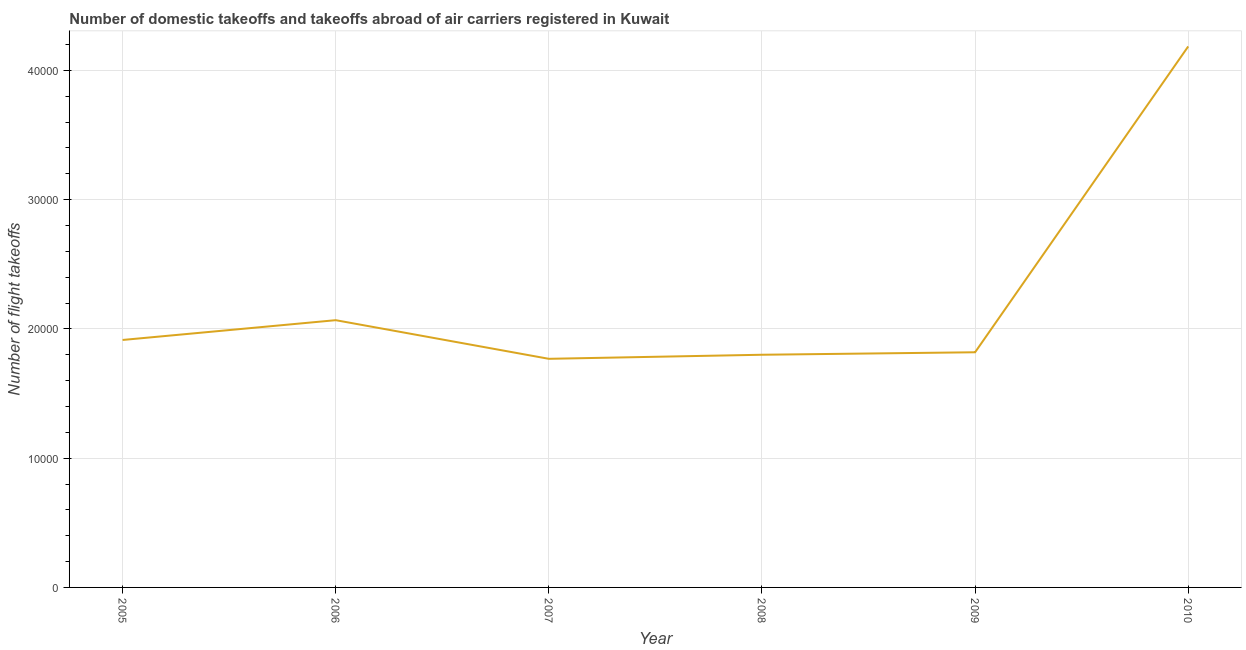What is the number of flight takeoffs in 2010?
Your answer should be very brief. 4.18e+04. Across all years, what is the maximum number of flight takeoffs?
Give a very brief answer. 4.18e+04. Across all years, what is the minimum number of flight takeoffs?
Offer a terse response. 1.77e+04. In which year was the number of flight takeoffs maximum?
Provide a short and direct response. 2010. What is the sum of the number of flight takeoffs?
Make the answer very short. 1.36e+05. What is the difference between the number of flight takeoffs in 2008 and 2009?
Keep it short and to the point. -192. What is the average number of flight takeoffs per year?
Ensure brevity in your answer.  2.26e+04. What is the median number of flight takeoffs?
Provide a short and direct response. 1.87e+04. In how many years, is the number of flight takeoffs greater than 14000 ?
Ensure brevity in your answer.  6. Do a majority of the years between 2010 and 2008 (inclusive) have number of flight takeoffs greater than 6000 ?
Your answer should be compact. No. What is the ratio of the number of flight takeoffs in 2006 to that in 2008?
Provide a short and direct response. 1.15. Is the difference between the number of flight takeoffs in 2006 and 2008 greater than the difference between any two years?
Provide a succinct answer. No. What is the difference between the highest and the second highest number of flight takeoffs?
Provide a succinct answer. 2.12e+04. Is the sum of the number of flight takeoffs in 2005 and 2006 greater than the maximum number of flight takeoffs across all years?
Provide a short and direct response. No. What is the difference between the highest and the lowest number of flight takeoffs?
Make the answer very short. 2.42e+04. In how many years, is the number of flight takeoffs greater than the average number of flight takeoffs taken over all years?
Provide a short and direct response. 1. Does the number of flight takeoffs monotonically increase over the years?
Ensure brevity in your answer.  No. How many years are there in the graph?
Make the answer very short. 6. Does the graph contain any zero values?
Ensure brevity in your answer.  No. Does the graph contain grids?
Give a very brief answer. Yes. What is the title of the graph?
Give a very brief answer. Number of domestic takeoffs and takeoffs abroad of air carriers registered in Kuwait. What is the label or title of the Y-axis?
Your response must be concise. Number of flight takeoffs. What is the Number of flight takeoffs in 2005?
Offer a very short reply. 1.91e+04. What is the Number of flight takeoffs in 2006?
Give a very brief answer. 2.07e+04. What is the Number of flight takeoffs of 2007?
Make the answer very short. 1.77e+04. What is the Number of flight takeoffs of 2008?
Your answer should be compact. 1.80e+04. What is the Number of flight takeoffs of 2009?
Provide a succinct answer. 1.82e+04. What is the Number of flight takeoffs of 2010?
Make the answer very short. 4.18e+04. What is the difference between the Number of flight takeoffs in 2005 and 2006?
Keep it short and to the point. -1531. What is the difference between the Number of flight takeoffs in 2005 and 2007?
Ensure brevity in your answer.  1457. What is the difference between the Number of flight takeoffs in 2005 and 2008?
Offer a terse response. 1143. What is the difference between the Number of flight takeoffs in 2005 and 2009?
Your answer should be very brief. 951. What is the difference between the Number of flight takeoffs in 2005 and 2010?
Provide a short and direct response. -2.27e+04. What is the difference between the Number of flight takeoffs in 2006 and 2007?
Provide a short and direct response. 2988. What is the difference between the Number of flight takeoffs in 2006 and 2008?
Provide a succinct answer. 2674. What is the difference between the Number of flight takeoffs in 2006 and 2009?
Offer a very short reply. 2482. What is the difference between the Number of flight takeoffs in 2006 and 2010?
Offer a very short reply. -2.12e+04. What is the difference between the Number of flight takeoffs in 2007 and 2008?
Provide a short and direct response. -314. What is the difference between the Number of flight takeoffs in 2007 and 2009?
Your response must be concise. -506. What is the difference between the Number of flight takeoffs in 2007 and 2010?
Give a very brief answer. -2.42e+04. What is the difference between the Number of flight takeoffs in 2008 and 2009?
Your response must be concise. -192. What is the difference between the Number of flight takeoffs in 2008 and 2010?
Give a very brief answer. -2.38e+04. What is the difference between the Number of flight takeoffs in 2009 and 2010?
Make the answer very short. -2.37e+04. What is the ratio of the Number of flight takeoffs in 2005 to that in 2006?
Your answer should be compact. 0.93. What is the ratio of the Number of flight takeoffs in 2005 to that in 2007?
Your answer should be very brief. 1.08. What is the ratio of the Number of flight takeoffs in 2005 to that in 2008?
Provide a succinct answer. 1.06. What is the ratio of the Number of flight takeoffs in 2005 to that in 2009?
Make the answer very short. 1.05. What is the ratio of the Number of flight takeoffs in 2005 to that in 2010?
Your response must be concise. 0.46. What is the ratio of the Number of flight takeoffs in 2006 to that in 2007?
Provide a short and direct response. 1.17. What is the ratio of the Number of flight takeoffs in 2006 to that in 2008?
Give a very brief answer. 1.15. What is the ratio of the Number of flight takeoffs in 2006 to that in 2009?
Provide a succinct answer. 1.14. What is the ratio of the Number of flight takeoffs in 2006 to that in 2010?
Offer a very short reply. 0.49. What is the ratio of the Number of flight takeoffs in 2007 to that in 2008?
Provide a short and direct response. 0.98. What is the ratio of the Number of flight takeoffs in 2007 to that in 2010?
Give a very brief answer. 0.42. What is the ratio of the Number of flight takeoffs in 2008 to that in 2010?
Your answer should be very brief. 0.43. What is the ratio of the Number of flight takeoffs in 2009 to that in 2010?
Your answer should be compact. 0.43. 